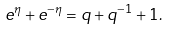Convert formula to latex. <formula><loc_0><loc_0><loc_500><loc_500>e ^ { \eta } + e ^ { - \eta } = q + q ^ { - 1 } + 1 .</formula> 